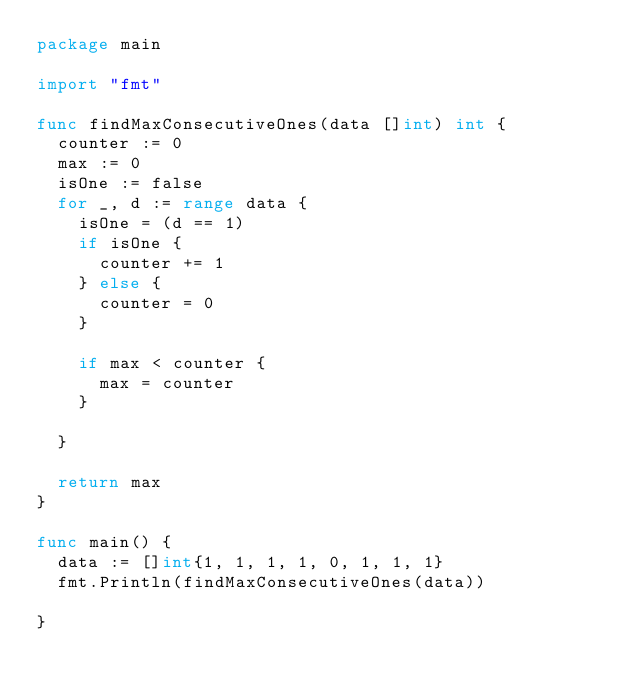Convert code to text. <code><loc_0><loc_0><loc_500><loc_500><_Go_>package main

import "fmt"

func findMaxConsecutiveOnes(data []int) int {
	counter := 0
	max := 0
	isOne := false
	for _, d := range data {
		isOne = (d == 1)
		if isOne {
			counter += 1
		} else {
			counter = 0
		}

		if max < counter {
			max = counter
		}
		
	}

	return max
}

func main() {
	data := []int{1, 1, 1, 1, 0, 1, 1, 1}
	fmt.Println(findMaxConsecutiveOnes(data))
	
}</code> 